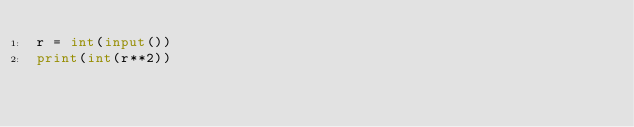<code> <loc_0><loc_0><loc_500><loc_500><_Python_>r = int(input())
print(int(r**2))</code> 